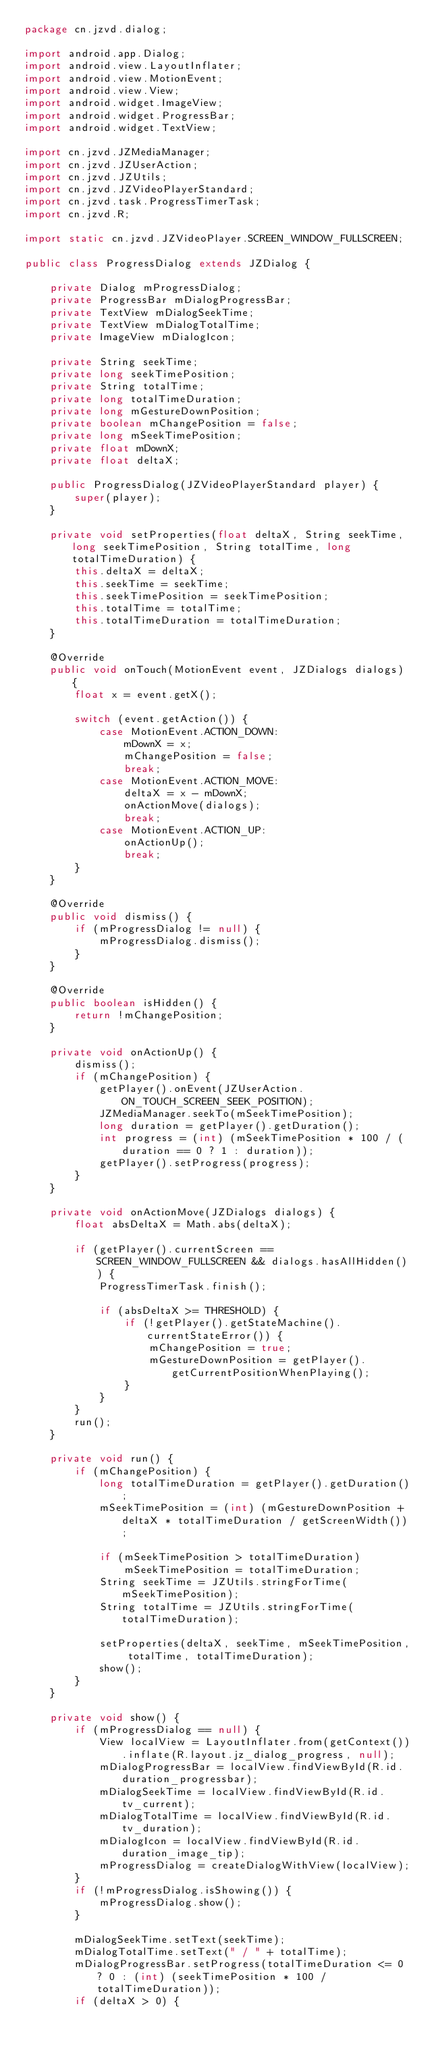<code> <loc_0><loc_0><loc_500><loc_500><_Java_>package cn.jzvd.dialog;

import android.app.Dialog;
import android.view.LayoutInflater;
import android.view.MotionEvent;
import android.view.View;
import android.widget.ImageView;
import android.widget.ProgressBar;
import android.widget.TextView;

import cn.jzvd.JZMediaManager;
import cn.jzvd.JZUserAction;
import cn.jzvd.JZUtils;
import cn.jzvd.JZVideoPlayerStandard;
import cn.jzvd.task.ProgressTimerTask;
import cn.jzvd.R;

import static cn.jzvd.JZVideoPlayer.SCREEN_WINDOW_FULLSCREEN;

public class ProgressDialog extends JZDialog {

    private Dialog mProgressDialog;
    private ProgressBar mDialogProgressBar;
    private TextView mDialogSeekTime;
    private TextView mDialogTotalTime;
    private ImageView mDialogIcon;

    private String seekTime;
    private long seekTimePosition;
    private String totalTime;
    private long totalTimeDuration;
    private long mGestureDownPosition;
    private boolean mChangePosition = false;
    private long mSeekTimePosition;
    private float mDownX;
    private float deltaX;

    public ProgressDialog(JZVideoPlayerStandard player) {
        super(player);
    }

    private void setProperties(float deltaX, String seekTime, long seekTimePosition, String totalTime, long totalTimeDuration) {
        this.deltaX = deltaX;
        this.seekTime = seekTime;
        this.seekTimePosition = seekTimePosition;
        this.totalTime = totalTime;
        this.totalTimeDuration = totalTimeDuration;
    }

    @Override
    public void onTouch(MotionEvent event, JZDialogs dialogs) {
        float x = event.getX();

        switch (event.getAction()) {
            case MotionEvent.ACTION_DOWN:
                mDownX = x;
                mChangePosition = false;
                break;
            case MotionEvent.ACTION_MOVE:
                deltaX = x - mDownX;
                onActionMove(dialogs);
                break;
            case MotionEvent.ACTION_UP:
                onActionUp();
                break;
        }
    }

    @Override
    public void dismiss() {
        if (mProgressDialog != null) {
            mProgressDialog.dismiss();
        }
    }

    @Override
    public boolean isHidden() {
        return !mChangePosition;
    }

    private void onActionUp() {
        dismiss();
        if (mChangePosition) {
            getPlayer().onEvent(JZUserAction.ON_TOUCH_SCREEN_SEEK_POSITION);
            JZMediaManager.seekTo(mSeekTimePosition);
            long duration = getPlayer().getDuration();
            int progress = (int) (mSeekTimePosition * 100 / (duration == 0 ? 1 : duration));
            getPlayer().setProgress(progress);
        }
    }

    private void onActionMove(JZDialogs dialogs) {
        float absDeltaX = Math.abs(deltaX);

        if (getPlayer().currentScreen == SCREEN_WINDOW_FULLSCREEN && dialogs.hasAllHidden()) {
            ProgressTimerTask.finish();

            if (absDeltaX >= THRESHOLD) {
                if (!getPlayer().getStateMachine().currentStateError()) {
                    mChangePosition = true;
                    mGestureDownPosition = getPlayer().getCurrentPositionWhenPlaying();
                }
            }
        }
        run();
    }

    private void run() {
        if (mChangePosition) {
            long totalTimeDuration = getPlayer().getDuration();
            mSeekTimePosition = (int) (mGestureDownPosition + deltaX * totalTimeDuration / getScreenWidth());

            if (mSeekTimePosition > totalTimeDuration)
                mSeekTimePosition = totalTimeDuration;
            String seekTime = JZUtils.stringForTime(mSeekTimePosition);
            String totalTime = JZUtils.stringForTime(totalTimeDuration);

            setProperties(deltaX, seekTime, mSeekTimePosition, totalTime, totalTimeDuration);
            show();
        }
    }

    private void show() {
        if (mProgressDialog == null) {
            View localView = LayoutInflater.from(getContext()).inflate(R.layout.jz_dialog_progress, null);
            mDialogProgressBar = localView.findViewById(R.id.duration_progressbar);
            mDialogSeekTime = localView.findViewById(R.id.tv_current);
            mDialogTotalTime = localView.findViewById(R.id.tv_duration);
            mDialogIcon = localView.findViewById(R.id.duration_image_tip);
            mProgressDialog = createDialogWithView(localView);
        }
        if (!mProgressDialog.isShowing()) {
            mProgressDialog.show();
        }

        mDialogSeekTime.setText(seekTime);
        mDialogTotalTime.setText(" / " + totalTime);
        mDialogProgressBar.setProgress(totalTimeDuration <= 0 ? 0 : (int) (seekTimePosition * 100 / totalTimeDuration));
        if (deltaX > 0) {</code> 